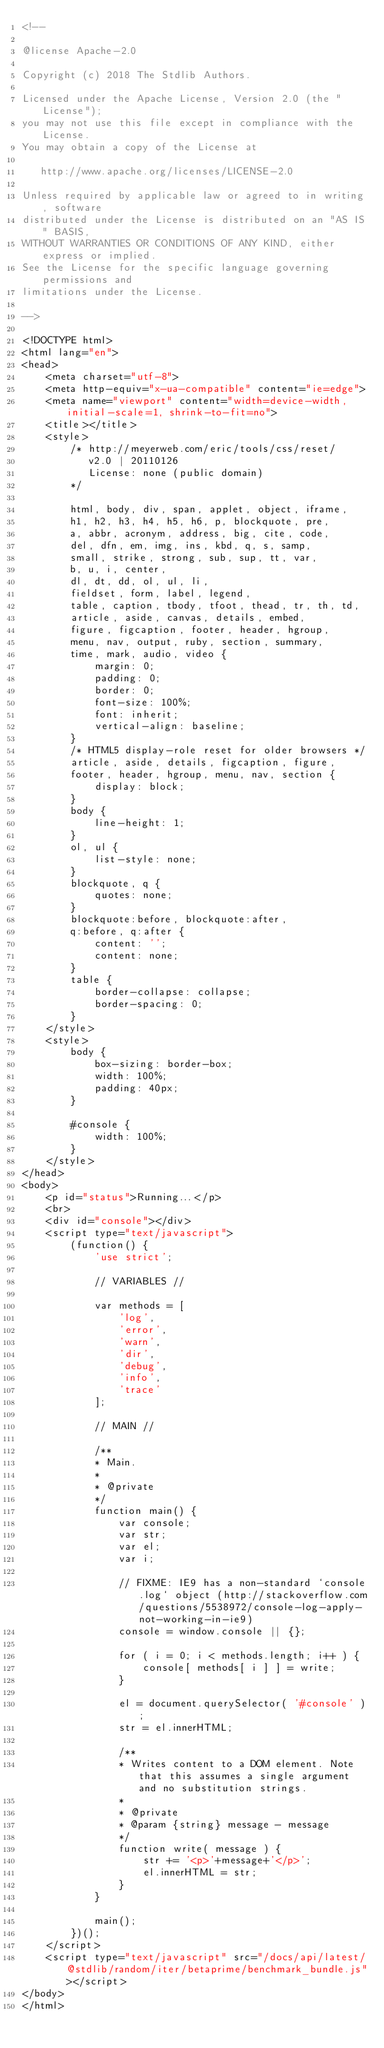Convert code to text. <code><loc_0><loc_0><loc_500><loc_500><_HTML_><!--

@license Apache-2.0

Copyright (c) 2018 The Stdlib Authors.

Licensed under the Apache License, Version 2.0 (the "License");
you may not use this file except in compliance with the License.
You may obtain a copy of the License at

   http://www.apache.org/licenses/LICENSE-2.0

Unless required by applicable law or agreed to in writing, software
distributed under the License is distributed on an "AS IS" BASIS,
WITHOUT WARRANTIES OR CONDITIONS OF ANY KIND, either express or implied.
See the License for the specific language governing permissions and
limitations under the License.

-->

<!DOCTYPE html>
<html lang="en">
<head>
	<meta charset="utf-8">
	<meta http-equiv="x-ua-compatible" content="ie=edge">
	<meta name="viewport" content="width=device-width, initial-scale=1, shrink-to-fit=no">
	<title></title>
	<style>
		/* http://meyerweb.com/eric/tools/css/reset/
		   v2.0 | 20110126
		   License: none (public domain)
		*/

		html, body, div, span, applet, object, iframe,
		h1, h2, h3, h4, h5, h6, p, blockquote, pre,
		a, abbr, acronym, address, big, cite, code,
		del, dfn, em, img, ins, kbd, q, s, samp,
		small, strike, strong, sub, sup, tt, var,
		b, u, i, center,
		dl, dt, dd, ol, ul, li,
		fieldset, form, label, legend,
		table, caption, tbody, tfoot, thead, tr, th, td,
		article, aside, canvas, details, embed,
		figure, figcaption, footer, header, hgroup,
		menu, nav, output, ruby, section, summary,
		time, mark, audio, video {
			margin: 0;
			padding: 0;
			border: 0;
			font-size: 100%;
			font: inherit;
			vertical-align: baseline;
		}
		/* HTML5 display-role reset for older browsers */
		article, aside, details, figcaption, figure,
		footer, header, hgroup, menu, nav, section {
			display: block;
		}
		body {
			line-height: 1;
		}
		ol, ul {
			list-style: none;
		}
		blockquote, q {
			quotes: none;
		}
		blockquote:before, blockquote:after,
		q:before, q:after {
			content: '';
			content: none;
		}
		table {
			border-collapse: collapse;
			border-spacing: 0;
		}
	</style>
	<style>
		body {
			box-sizing: border-box;
			width: 100%;
			padding: 40px;
		}

		#console {
			width: 100%;
		}
	</style>
</head>
<body>
	<p id="status">Running...</p>
	<br>
	<div id="console"></div>
	<script type="text/javascript">
		(function() {
			'use strict';

			// VARIABLES //

			var methods = [
				'log',
				'error',
				'warn',
				'dir',
				'debug',
				'info',
				'trace'
			];

			// MAIN //

			/**
			* Main.
			*
			* @private
			*/
			function main() {
				var console;
				var str;
				var el;
				var i;

				// FIXME: IE9 has a non-standard `console.log` object (http://stackoverflow.com/questions/5538972/console-log-apply-not-working-in-ie9)
				console = window.console || {};

				for ( i = 0; i < methods.length; i++ ) {
					console[ methods[ i ] ] = write;
				}

				el = document.querySelector( '#console' );
				str = el.innerHTML;

				/**
				* Writes content to a DOM element. Note that this assumes a single argument and no substitution strings.
				*
				* @private
				* @param {string} message - message
				*/
				function write( message ) {
					str += '<p>'+message+'</p>';
					el.innerHTML = str;
				}
			}

			main();
		})();
	</script>
	<script type="text/javascript" src="/docs/api/latest/@stdlib/random/iter/betaprime/benchmark_bundle.js"></script>
</body>
</html>
</code> 